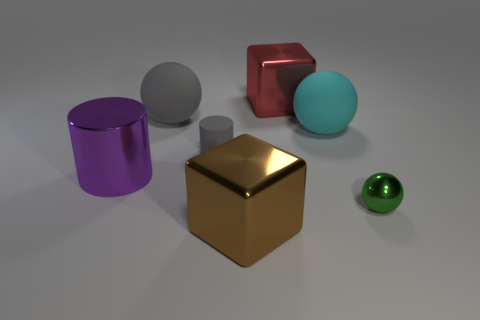What shape is the big shiny thing that is both in front of the large gray ball and right of the big purple cylinder?
Make the answer very short. Cube. How many other objects are there of the same shape as the small green thing?
Offer a terse response. 2. There is another rubber sphere that is the same size as the cyan rubber sphere; what color is it?
Keep it short and to the point. Gray. What number of things are tiny purple matte objects or red objects?
Offer a terse response. 1. Are there any large purple cylinders in front of the big purple object?
Keep it short and to the point. No. Are there any red things made of the same material as the gray cylinder?
Offer a very short reply. No. The other thing that is the same color as the tiny matte thing is what size?
Offer a terse response. Large. What number of cylinders are either gray matte things or brown shiny objects?
Offer a very short reply. 1. Are there more big objects that are on the right side of the large cyan sphere than cyan balls to the left of the gray rubber sphere?
Keep it short and to the point. No. What number of large matte balls have the same color as the matte cylinder?
Offer a terse response. 1. 